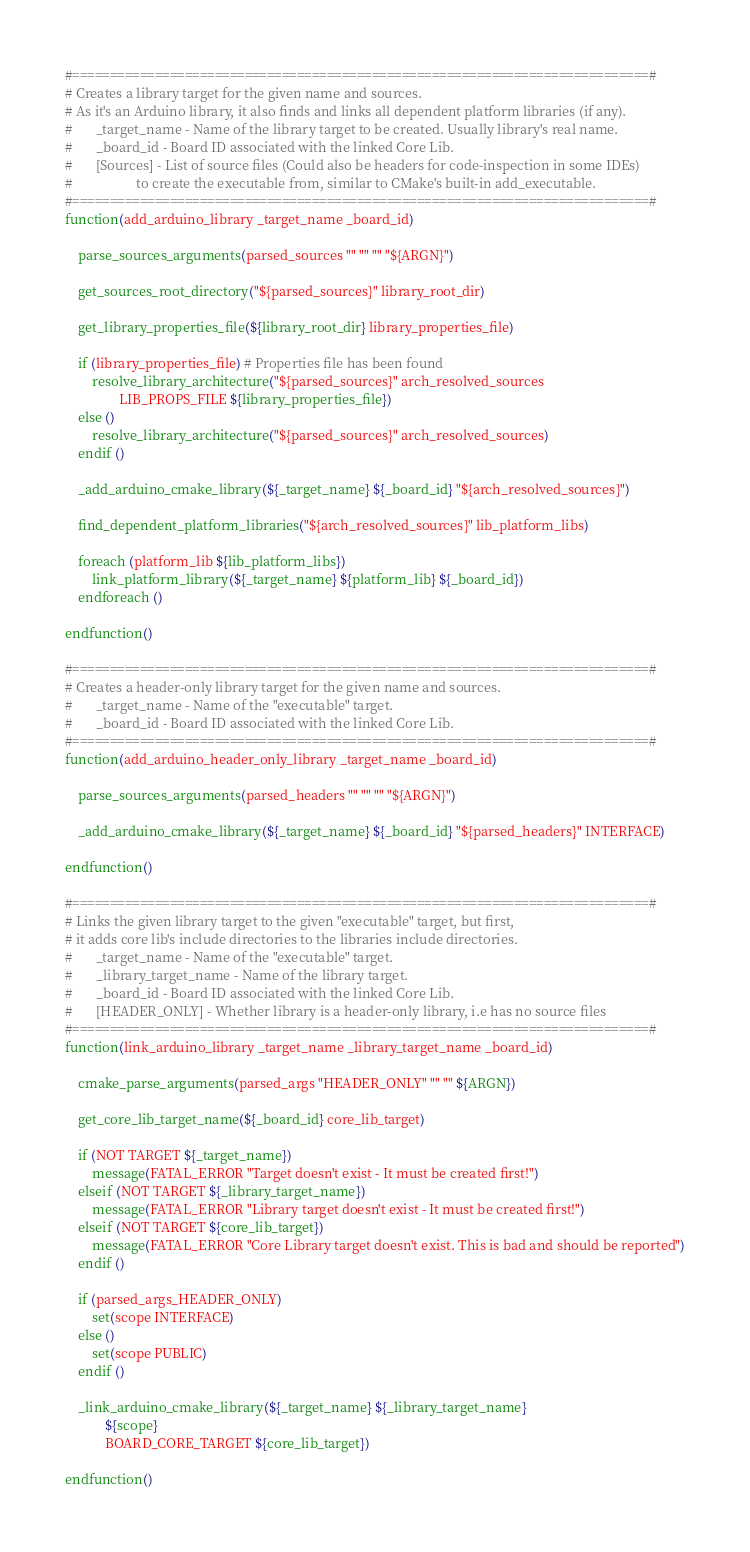<code> <loc_0><loc_0><loc_500><loc_500><_CMake_>#=============================================================================#
# Creates a library target for the given name and sources.
# As it's an Arduino library, it also finds and links all dependent platform libraries (if any).
#       _target_name - Name of the library target to be created. Usually library's real name.
#       _board_id - Board ID associated with the linked Core Lib.
#       [Sources] - List of source files (Could also be headers for code-inspection in some IDEs)
#                   to create the executable from, similar to CMake's built-in add_executable.
#=============================================================================#
function(add_arduino_library _target_name _board_id)

    parse_sources_arguments(parsed_sources "" "" "" "${ARGN}")

    get_sources_root_directory("${parsed_sources}" library_root_dir)

    get_library_properties_file(${library_root_dir} library_properties_file)

    if (library_properties_file) # Properties file has been found
        resolve_library_architecture("${parsed_sources}" arch_resolved_sources
                LIB_PROPS_FILE ${library_properties_file})
    else ()
        resolve_library_architecture("${parsed_sources}" arch_resolved_sources)
    endif ()

    _add_arduino_cmake_library(${_target_name} ${_board_id} "${arch_resolved_sources}")

    find_dependent_platform_libraries("${arch_resolved_sources}" lib_platform_libs)

    foreach (platform_lib ${lib_platform_libs})
        link_platform_library(${_target_name} ${platform_lib} ${_board_id})
    endforeach ()

endfunction()

#=============================================================================#
# Creates a header-only library target for the given name and sources.
#       _target_name - Name of the "executable" target.
#       _board_id - Board ID associated with the linked Core Lib.
#=============================================================================#
function(add_arduino_header_only_library _target_name _board_id)

    parse_sources_arguments(parsed_headers "" "" "" "${ARGN}")

    _add_arduino_cmake_library(${_target_name} ${_board_id} "${parsed_headers}" INTERFACE)

endfunction()

#=============================================================================#
# Links the given library target to the given "executable" target, but first,
# it adds core lib's include directories to the libraries include directories.
#       _target_name - Name of the "executable" target.
#       _library_target_name - Name of the library target.
#       _board_id - Board ID associated with the linked Core Lib.
#       [HEADER_ONLY] - Whether library is a header-only library, i.e has no source files
#=============================================================================#
function(link_arduino_library _target_name _library_target_name _board_id)

    cmake_parse_arguments(parsed_args "HEADER_ONLY" "" "" ${ARGN})

    get_core_lib_target_name(${_board_id} core_lib_target)

    if (NOT TARGET ${_target_name})
        message(FATAL_ERROR "Target doesn't exist - It must be created first!")
    elseif (NOT TARGET ${_library_target_name})
        message(FATAL_ERROR "Library target doesn't exist - It must be created first!")
    elseif (NOT TARGET ${core_lib_target})
        message(FATAL_ERROR "Core Library target doesn't exist. This is bad and should be reported")
    endif ()

    if (parsed_args_HEADER_ONLY)
        set(scope INTERFACE)
    else ()
        set(scope PUBLIC)
    endif ()

    _link_arduino_cmake_library(${_target_name} ${_library_target_name}
            ${scope}
            BOARD_CORE_TARGET ${core_lib_target})

endfunction()
</code> 